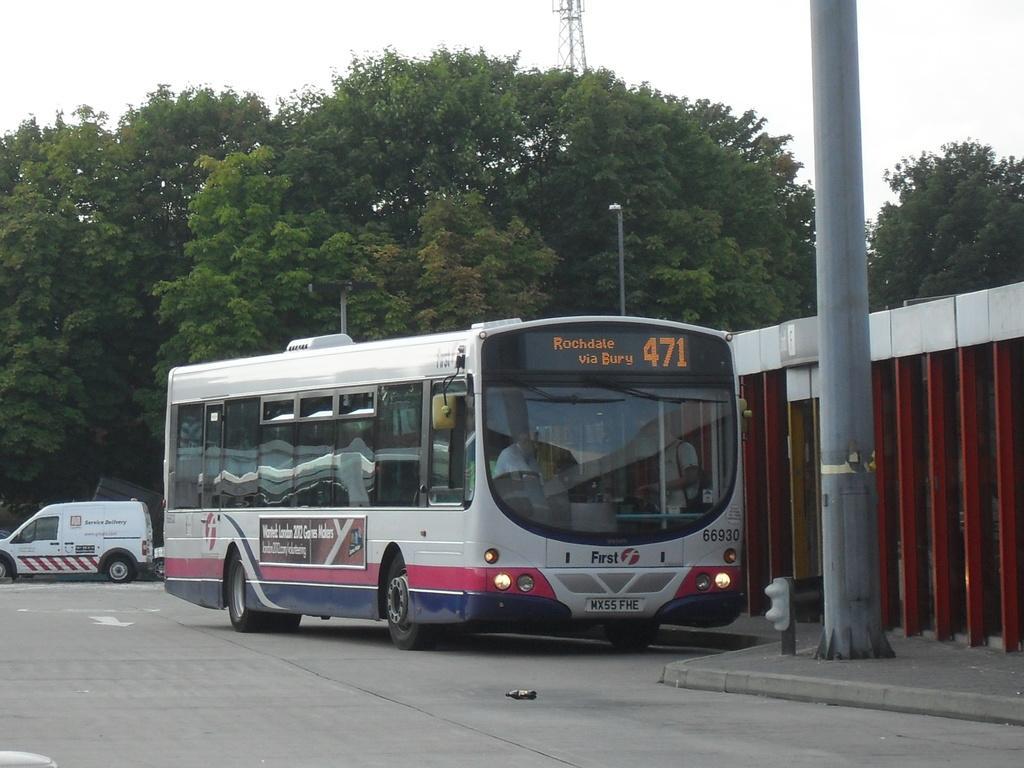How would you summarize this image in a sentence or two? Vehicles are on the road. In-front of this bus there is a pole. Background there are a number of trees. People are inside this bus.  